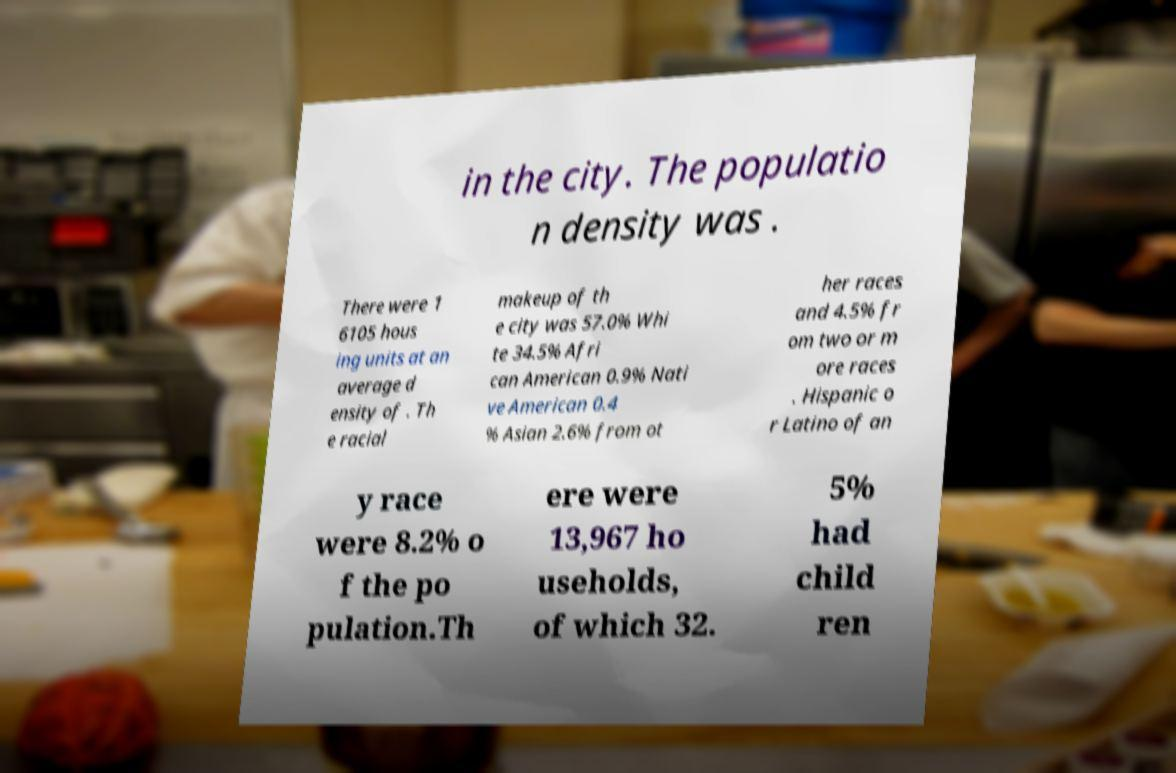For documentation purposes, I need the text within this image transcribed. Could you provide that? in the city. The populatio n density was . There were 1 6105 hous ing units at an average d ensity of . Th e racial makeup of th e city was 57.0% Whi te 34.5% Afri can American 0.9% Nati ve American 0.4 % Asian 2.6% from ot her races and 4.5% fr om two or m ore races . Hispanic o r Latino of an y race were 8.2% o f the po pulation.Th ere were 13,967 ho useholds, of which 32. 5% had child ren 